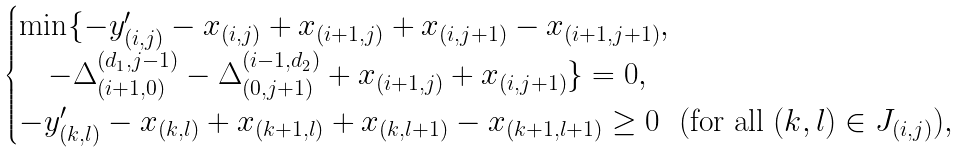Convert formula to latex. <formula><loc_0><loc_0><loc_500><loc_500>\begin{cases} \min \{ - y _ { ( i , j ) } ^ { \prime } - x _ { ( i , j ) } + x _ { ( i + 1 , j ) } + x _ { ( i , j + 1 ) } - x _ { ( i + 1 , j + 1 ) } , \\ \quad - \Delta _ { ( i + 1 , 0 ) } ^ { ( d _ { 1 } , j - 1 ) } - \Delta _ { ( 0 , j + 1 ) } ^ { ( i - 1 , d _ { 2 } ) } + x _ { ( i + 1 , j ) } + x _ { ( i , j + 1 ) } \} = 0 , \\ - y _ { ( k , l ) } ^ { \prime } - x _ { ( k , l ) } + x _ { ( k + 1 , l ) } + x _ { ( k , l + 1 ) } - x _ { ( k + 1 , l + 1 ) } \geq 0 \ \ ( \text {for all} \ ( k , l ) \in J _ { ( i , j ) } ) , \end{cases}</formula> 